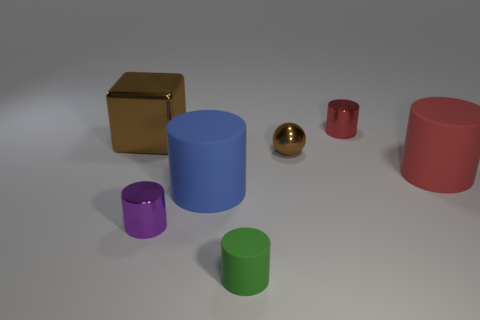There is a blue thing in front of the brown cube; what is its size?
Offer a terse response. Large. How many red cylinders have the same size as the brown cube?
Your answer should be compact. 1. Is the size of the blue rubber cylinder the same as the red cylinder that is in front of the large brown object?
Ensure brevity in your answer.  Yes. What number of objects are either small brown spheres or cylinders?
Ensure brevity in your answer.  6. What number of metallic cubes are the same color as the small shiny sphere?
Offer a terse response. 1. There is a red matte object that is the same size as the shiny block; what is its shape?
Provide a short and direct response. Cylinder. Are there any small red things of the same shape as the large brown metal object?
Give a very brief answer. No. What number of big objects are the same material as the purple cylinder?
Offer a terse response. 1. Is the material of the cylinder behind the big red matte object the same as the large blue cylinder?
Offer a terse response. No. Is the number of red rubber cylinders that are in front of the brown metal block greater than the number of red things right of the large red object?
Ensure brevity in your answer.  Yes. 